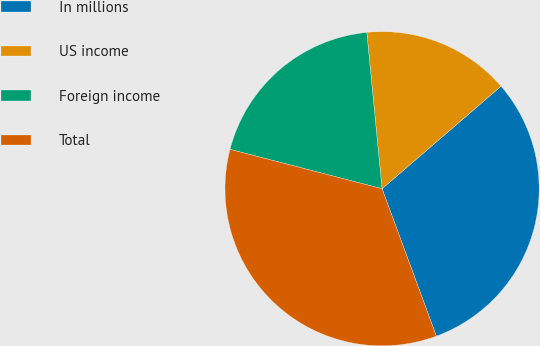Convert chart. <chart><loc_0><loc_0><loc_500><loc_500><pie_chart><fcel>In millions<fcel>US income<fcel>Foreign income<fcel>Total<nl><fcel>30.7%<fcel>15.23%<fcel>19.42%<fcel>34.65%<nl></chart> 